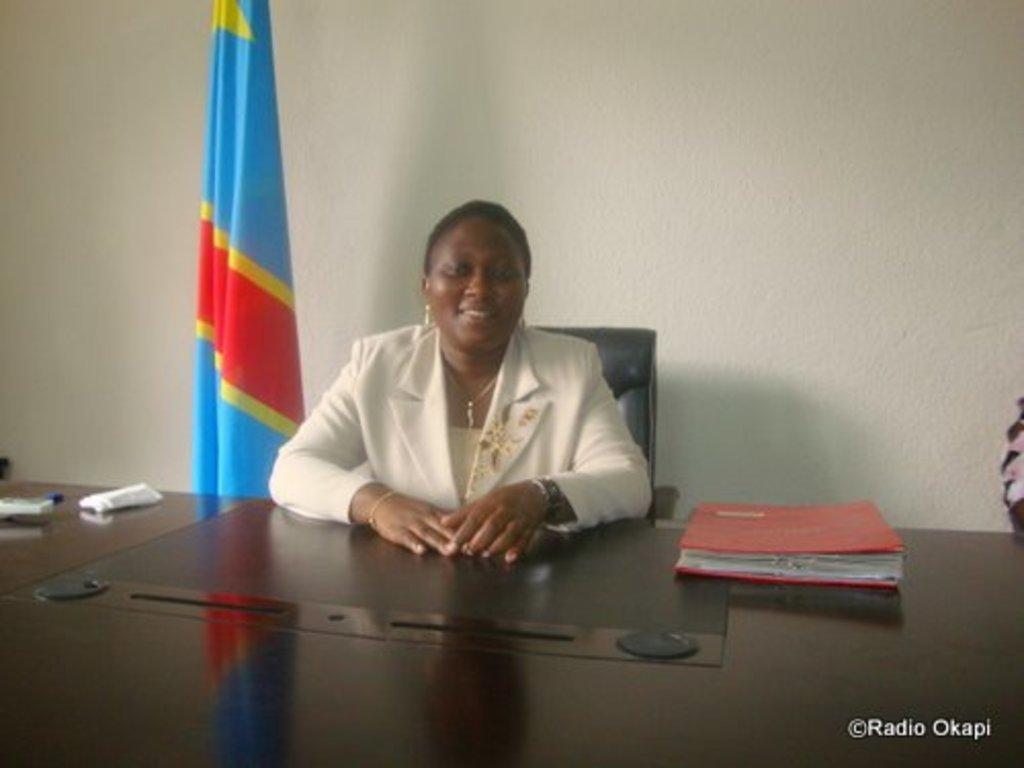Please provide a concise description of this image. In this image I can see a woman is sitting on a chair. I can see she is wearing white colour dress and a necklace. In the front of her I can see a table and on it I can see a red colour file, few white colour things and other stuffs. I can also see a watermark on the bottom right side of this image and in the background I can see a flag and the wall. 